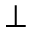Convert formula to latex. <formula><loc_0><loc_0><loc_500><loc_500>\bot</formula> 